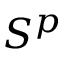Convert formula to latex. <formula><loc_0><loc_0><loc_500><loc_500>S ^ { p }</formula> 